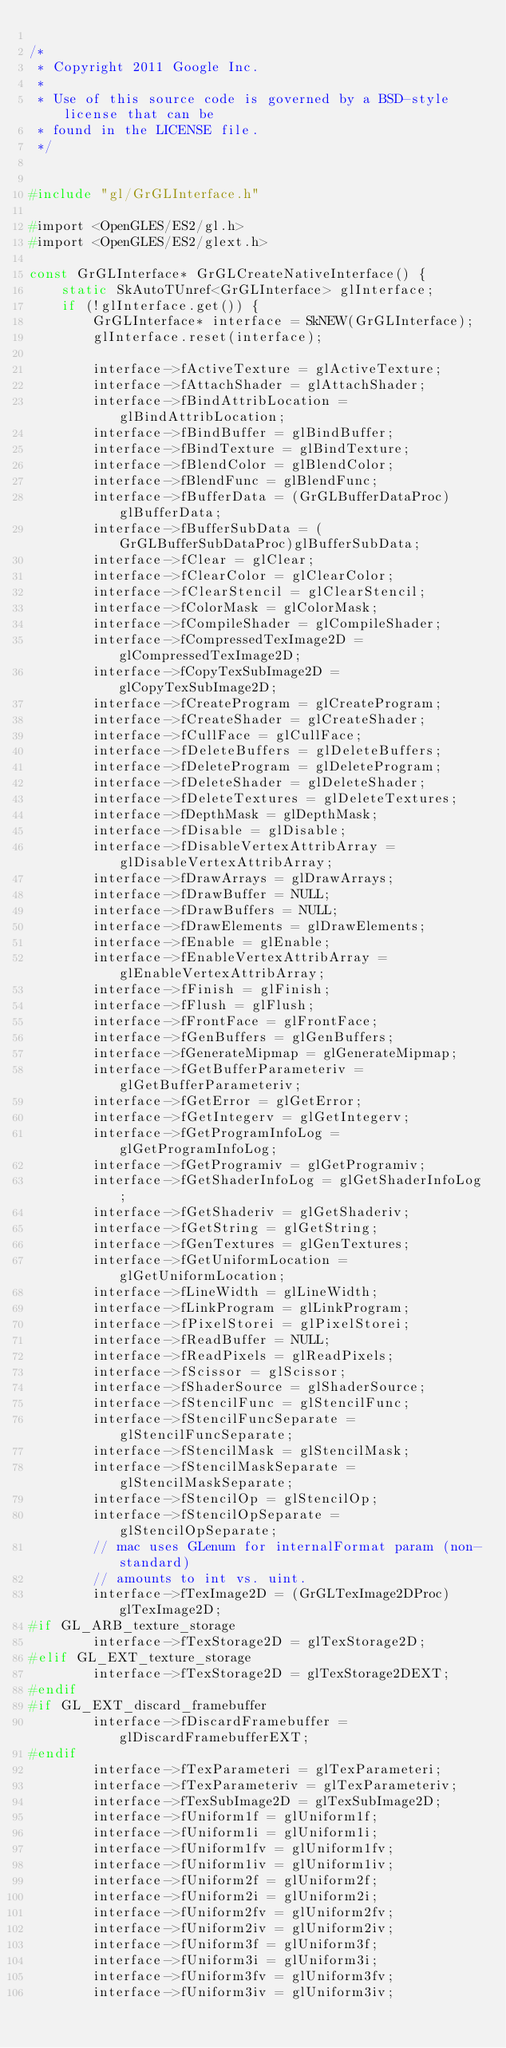Convert code to text. <code><loc_0><loc_0><loc_500><loc_500><_C++_>
/*
 * Copyright 2011 Google Inc.
 *
 * Use of this source code is governed by a BSD-style license that can be
 * found in the LICENSE file.
 */


#include "gl/GrGLInterface.h"

#import <OpenGLES/ES2/gl.h>
#import <OpenGLES/ES2/glext.h>

const GrGLInterface* GrGLCreateNativeInterface() {
    static SkAutoTUnref<GrGLInterface> glInterface;
    if (!glInterface.get()) {
        GrGLInterface* interface = SkNEW(GrGLInterface);
        glInterface.reset(interface);

        interface->fActiveTexture = glActiveTexture;
        interface->fAttachShader = glAttachShader;
        interface->fBindAttribLocation = glBindAttribLocation;
        interface->fBindBuffer = glBindBuffer;
        interface->fBindTexture = glBindTexture;
        interface->fBlendColor = glBlendColor;
        interface->fBlendFunc = glBlendFunc;
        interface->fBufferData = (GrGLBufferDataProc)glBufferData;
        interface->fBufferSubData = (GrGLBufferSubDataProc)glBufferSubData;
        interface->fClear = glClear;
        interface->fClearColor = glClearColor;
        interface->fClearStencil = glClearStencil;
        interface->fColorMask = glColorMask;
        interface->fCompileShader = glCompileShader;
        interface->fCompressedTexImage2D = glCompressedTexImage2D;
        interface->fCopyTexSubImage2D = glCopyTexSubImage2D;
        interface->fCreateProgram = glCreateProgram;
        interface->fCreateShader = glCreateShader;
        interface->fCullFace = glCullFace;
        interface->fDeleteBuffers = glDeleteBuffers;
        interface->fDeleteProgram = glDeleteProgram;
        interface->fDeleteShader = glDeleteShader;
        interface->fDeleteTextures = glDeleteTextures;
        interface->fDepthMask = glDepthMask;
        interface->fDisable = glDisable;
        interface->fDisableVertexAttribArray = glDisableVertexAttribArray;
        interface->fDrawArrays = glDrawArrays;
        interface->fDrawBuffer = NULL;
        interface->fDrawBuffers = NULL;
        interface->fDrawElements = glDrawElements;
        interface->fEnable = glEnable;
        interface->fEnableVertexAttribArray = glEnableVertexAttribArray;
        interface->fFinish = glFinish;
        interface->fFlush = glFlush;
        interface->fFrontFace = glFrontFace;
        interface->fGenBuffers = glGenBuffers;
        interface->fGenerateMipmap = glGenerateMipmap;
        interface->fGetBufferParameteriv = glGetBufferParameteriv;
        interface->fGetError = glGetError;
        interface->fGetIntegerv = glGetIntegerv;
        interface->fGetProgramInfoLog = glGetProgramInfoLog;
        interface->fGetProgramiv = glGetProgramiv;
        interface->fGetShaderInfoLog = glGetShaderInfoLog;
        interface->fGetShaderiv = glGetShaderiv;
        interface->fGetString = glGetString;
        interface->fGenTextures = glGenTextures;
        interface->fGetUniformLocation = glGetUniformLocation;
        interface->fLineWidth = glLineWidth;
        interface->fLinkProgram = glLinkProgram;
        interface->fPixelStorei = glPixelStorei;
        interface->fReadBuffer = NULL;
        interface->fReadPixels = glReadPixels;
        interface->fScissor = glScissor;
        interface->fShaderSource = glShaderSource;
        interface->fStencilFunc = glStencilFunc;
        interface->fStencilFuncSeparate = glStencilFuncSeparate;
        interface->fStencilMask = glStencilMask;
        interface->fStencilMaskSeparate = glStencilMaskSeparate;
        interface->fStencilOp = glStencilOp;
        interface->fStencilOpSeparate = glStencilOpSeparate;
        // mac uses GLenum for internalFormat param (non-standard)
        // amounts to int vs. uint.
        interface->fTexImage2D = (GrGLTexImage2DProc)glTexImage2D;
#if GL_ARB_texture_storage
        interface->fTexStorage2D = glTexStorage2D;
#elif GL_EXT_texture_storage
        interface->fTexStorage2D = glTexStorage2DEXT;
#endif
#if GL_EXT_discard_framebuffer
        interface->fDiscardFramebuffer = glDiscardFramebufferEXT;
#endif
        interface->fTexParameteri = glTexParameteri;
        interface->fTexParameteriv = glTexParameteriv;
        interface->fTexSubImage2D = glTexSubImage2D;
        interface->fUniform1f = glUniform1f;
        interface->fUniform1i = glUniform1i;
        interface->fUniform1fv = glUniform1fv;
        interface->fUniform1iv = glUniform1iv;
        interface->fUniform2f = glUniform2f;
        interface->fUniform2i = glUniform2i;
        interface->fUniform2fv = glUniform2fv;
        interface->fUniform2iv = glUniform2iv;
        interface->fUniform3f = glUniform3f;
        interface->fUniform3i = glUniform3i;
        interface->fUniform3fv = glUniform3fv;
        interface->fUniform3iv = glUniform3iv;</code> 